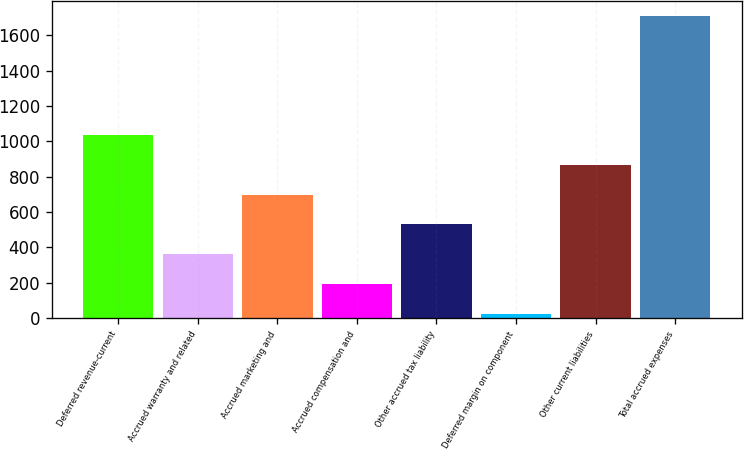<chart> <loc_0><loc_0><loc_500><loc_500><bar_chart><fcel>Deferred revenue-current<fcel>Accrued warranty and related<fcel>Accrued marketing and<fcel>Accrued compensation and<fcel>Other accrued tax liability<fcel>Deferred margin on component<fcel>Other current liabilities<fcel>Total accrued expenses<nl><fcel>1035.2<fcel>362.4<fcel>698.8<fcel>194.2<fcel>530.6<fcel>26<fcel>867<fcel>1708<nl></chart> 